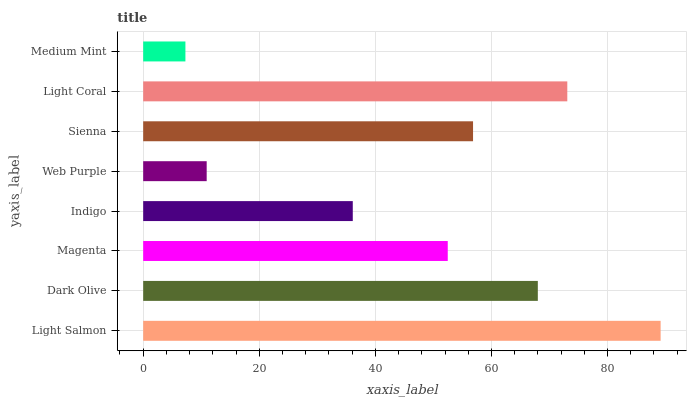Is Medium Mint the minimum?
Answer yes or no. Yes. Is Light Salmon the maximum?
Answer yes or no. Yes. Is Dark Olive the minimum?
Answer yes or no. No. Is Dark Olive the maximum?
Answer yes or no. No. Is Light Salmon greater than Dark Olive?
Answer yes or no. Yes. Is Dark Olive less than Light Salmon?
Answer yes or no. Yes. Is Dark Olive greater than Light Salmon?
Answer yes or no. No. Is Light Salmon less than Dark Olive?
Answer yes or no. No. Is Sienna the high median?
Answer yes or no. Yes. Is Magenta the low median?
Answer yes or no. Yes. Is Medium Mint the high median?
Answer yes or no. No. Is Sienna the low median?
Answer yes or no. No. 